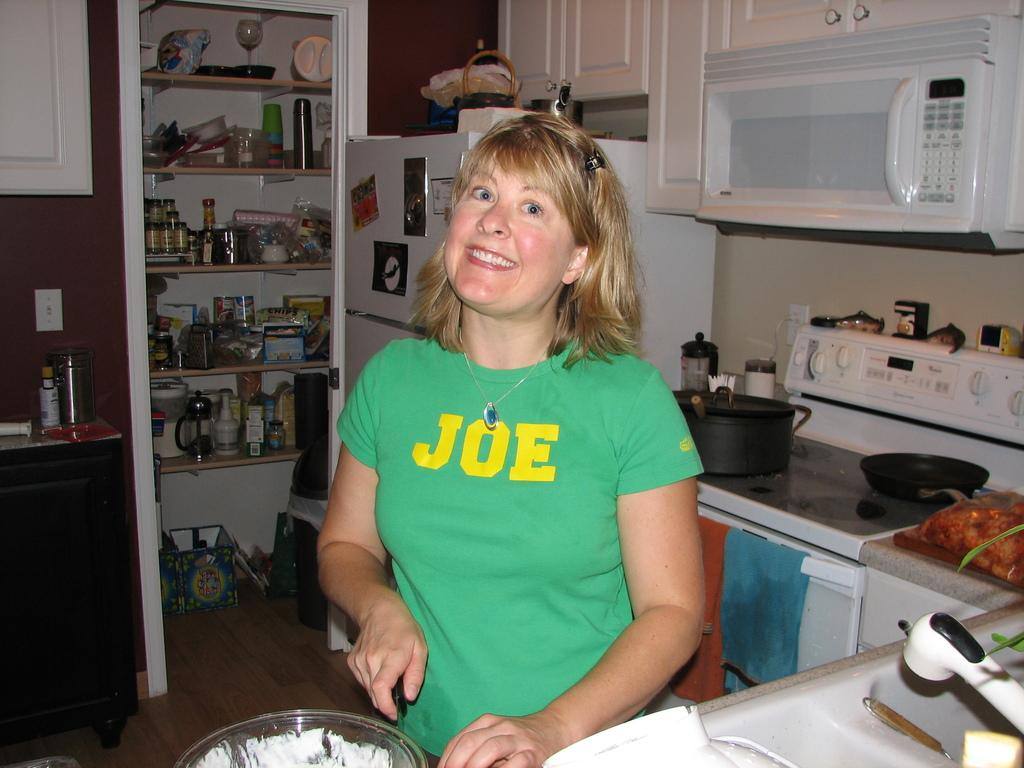Provide a one-sentence caption for the provided image. a woman smiling with a JOE T-shirt on in her kitchen. 